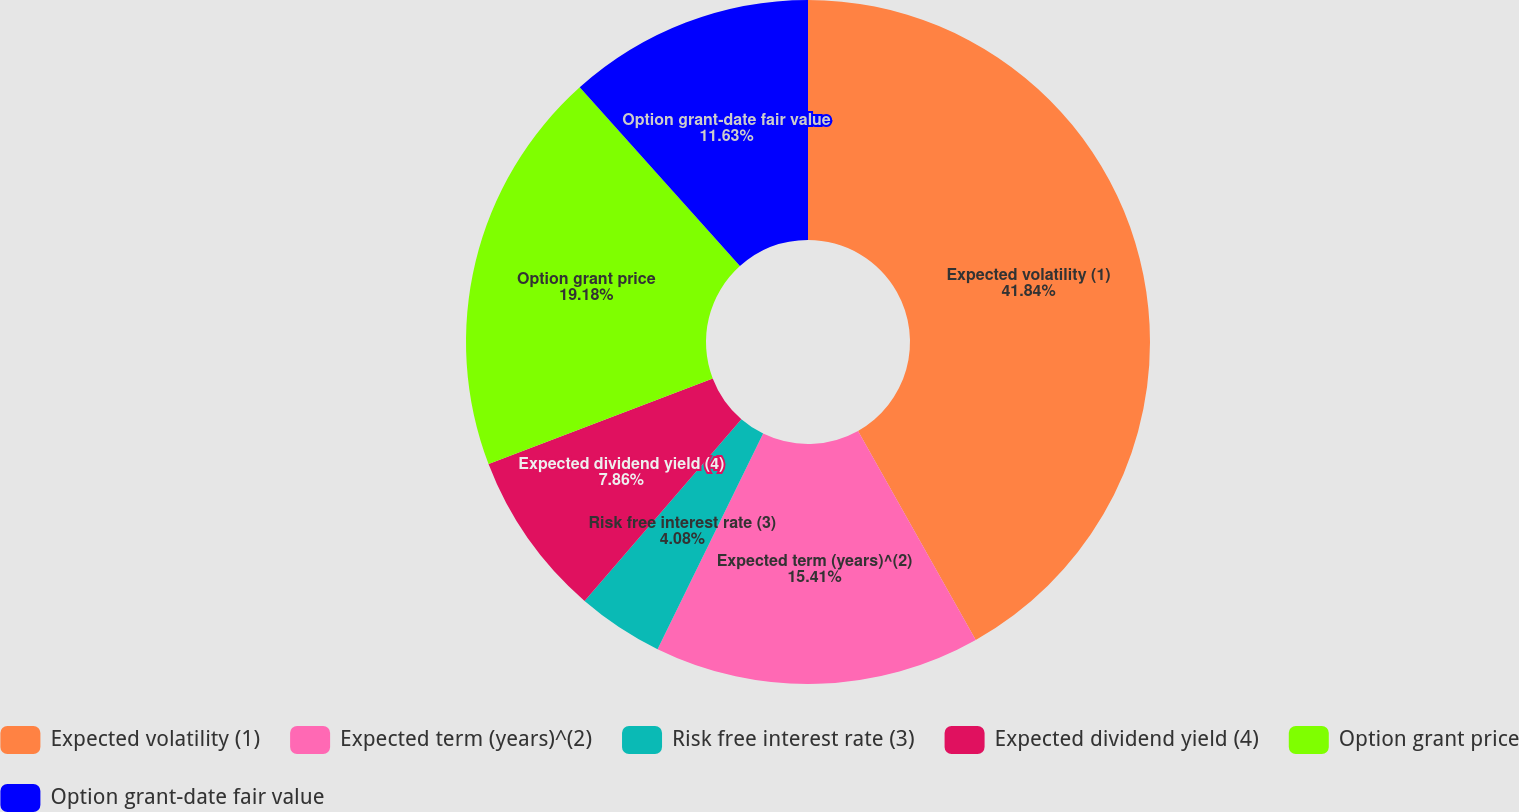Convert chart to OTSL. <chart><loc_0><loc_0><loc_500><loc_500><pie_chart><fcel>Expected volatility (1)<fcel>Expected term (years)^(2)<fcel>Risk free interest rate (3)<fcel>Expected dividend yield (4)<fcel>Option grant price<fcel>Option grant-date fair value<nl><fcel>41.84%<fcel>15.41%<fcel>4.08%<fcel>7.86%<fcel>19.18%<fcel>11.63%<nl></chart> 